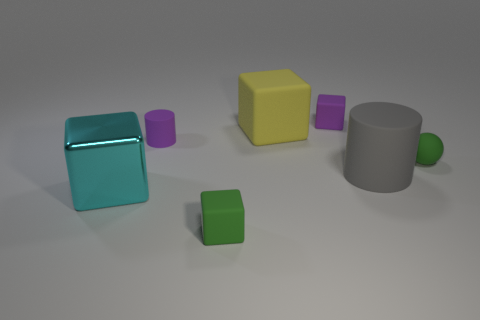Add 1 purple matte cubes. How many objects exist? 8 Subtract all large yellow matte cubes. How many cubes are left? 3 Subtract 1 cubes. How many cubes are left? 3 Subtract all balls. How many objects are left? 6 Subtract all brown blocks. Subtract all green cylinders. How many blocks are left? 4 Subtract 0 green cylinders. How many objects are left? 7 Subtract all tiny cyan metallic cubes. Subtract all big cyan blocks. How many objects are left? 6 Add 5 tiny purple cubes. How many tiny purple cubes are left? 6 Add 3 cubes. How many cubes exist? 7 